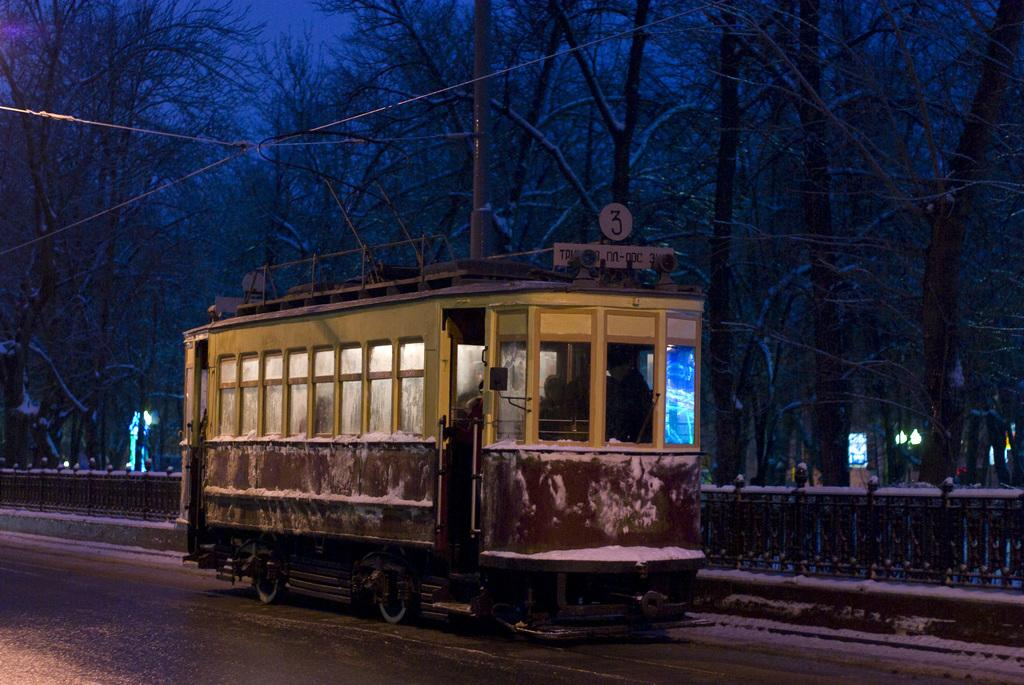What is the main subject in the center of the image? There is a bus in the center of the image. What are the people in the image doing? People are sitting in the bus. What can be seen in the background of the image? There are trees and a pole in the background of the image. What is present at the bottom of the image? There is a fence and snow visible at the bottom of the image. Can you see a boat floating in the snow at the bottom of the image? No, there is no boat visible in the image. The bottom of the image features a fence and snow, but no boat is present. 